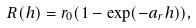Convert formula to latex. <formula><loc_0><loc_0><loc_500><loc_500>R ( h ) = r _ { 0 } ( 1 - \exp ( - a _ { r } h ) ) ,</formula> 